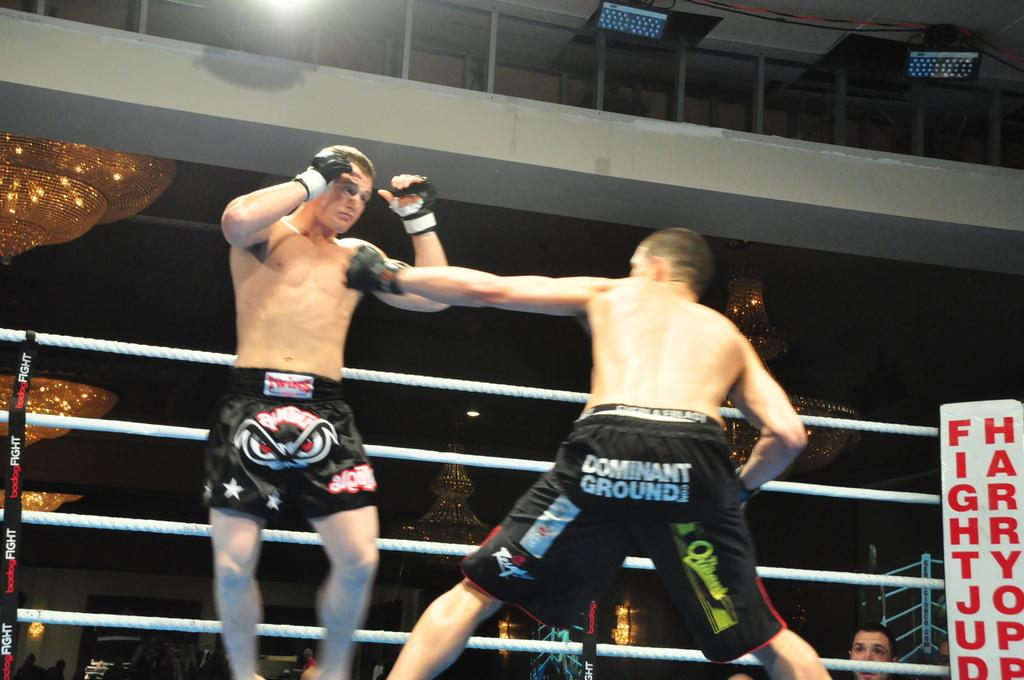<image>
Write a terse but informative summary of the picture. Two boxers, one of whom has the word Dominant on his shorts. 